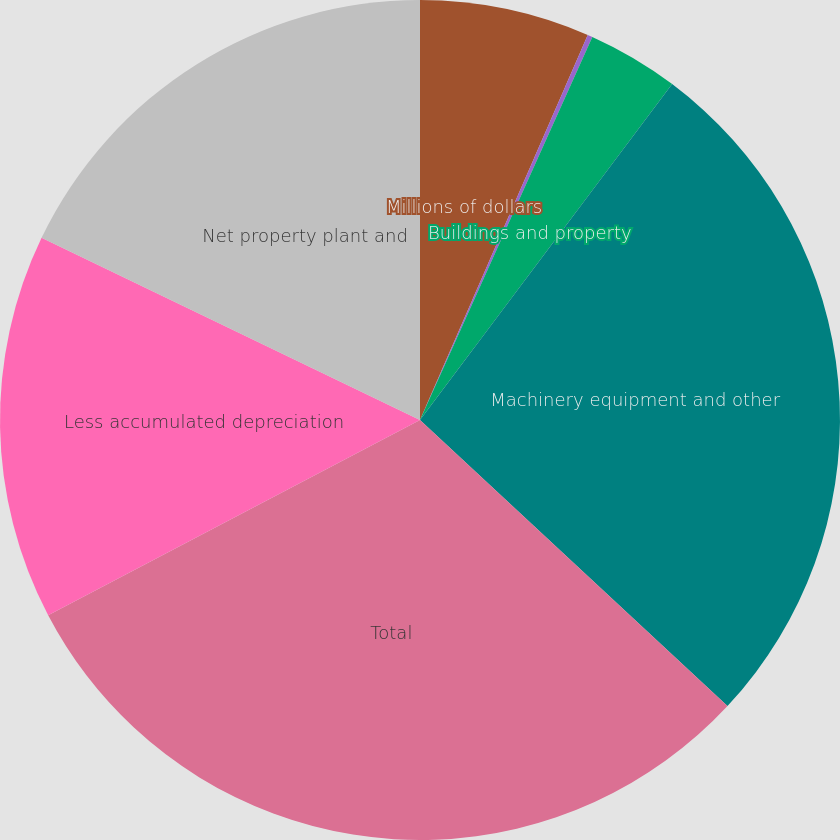Convert chart. <chart><loc_0><loc_0><loc_500><loc_500><pie_chart><fcel>Millions of dollars<fcel>Land<fcel>Buildings and property<fcel>Machinery equipment and other<fcel>Total<fcel>Less accumulated depreciation<fcel>Net property plant and<nl><fcel>6.54%<fcel>0.19%<fcel>3.52%<fcel>26.68%<fcel>30.38%<fcel>14.84%<fcel>17.86%<nl></chart> 